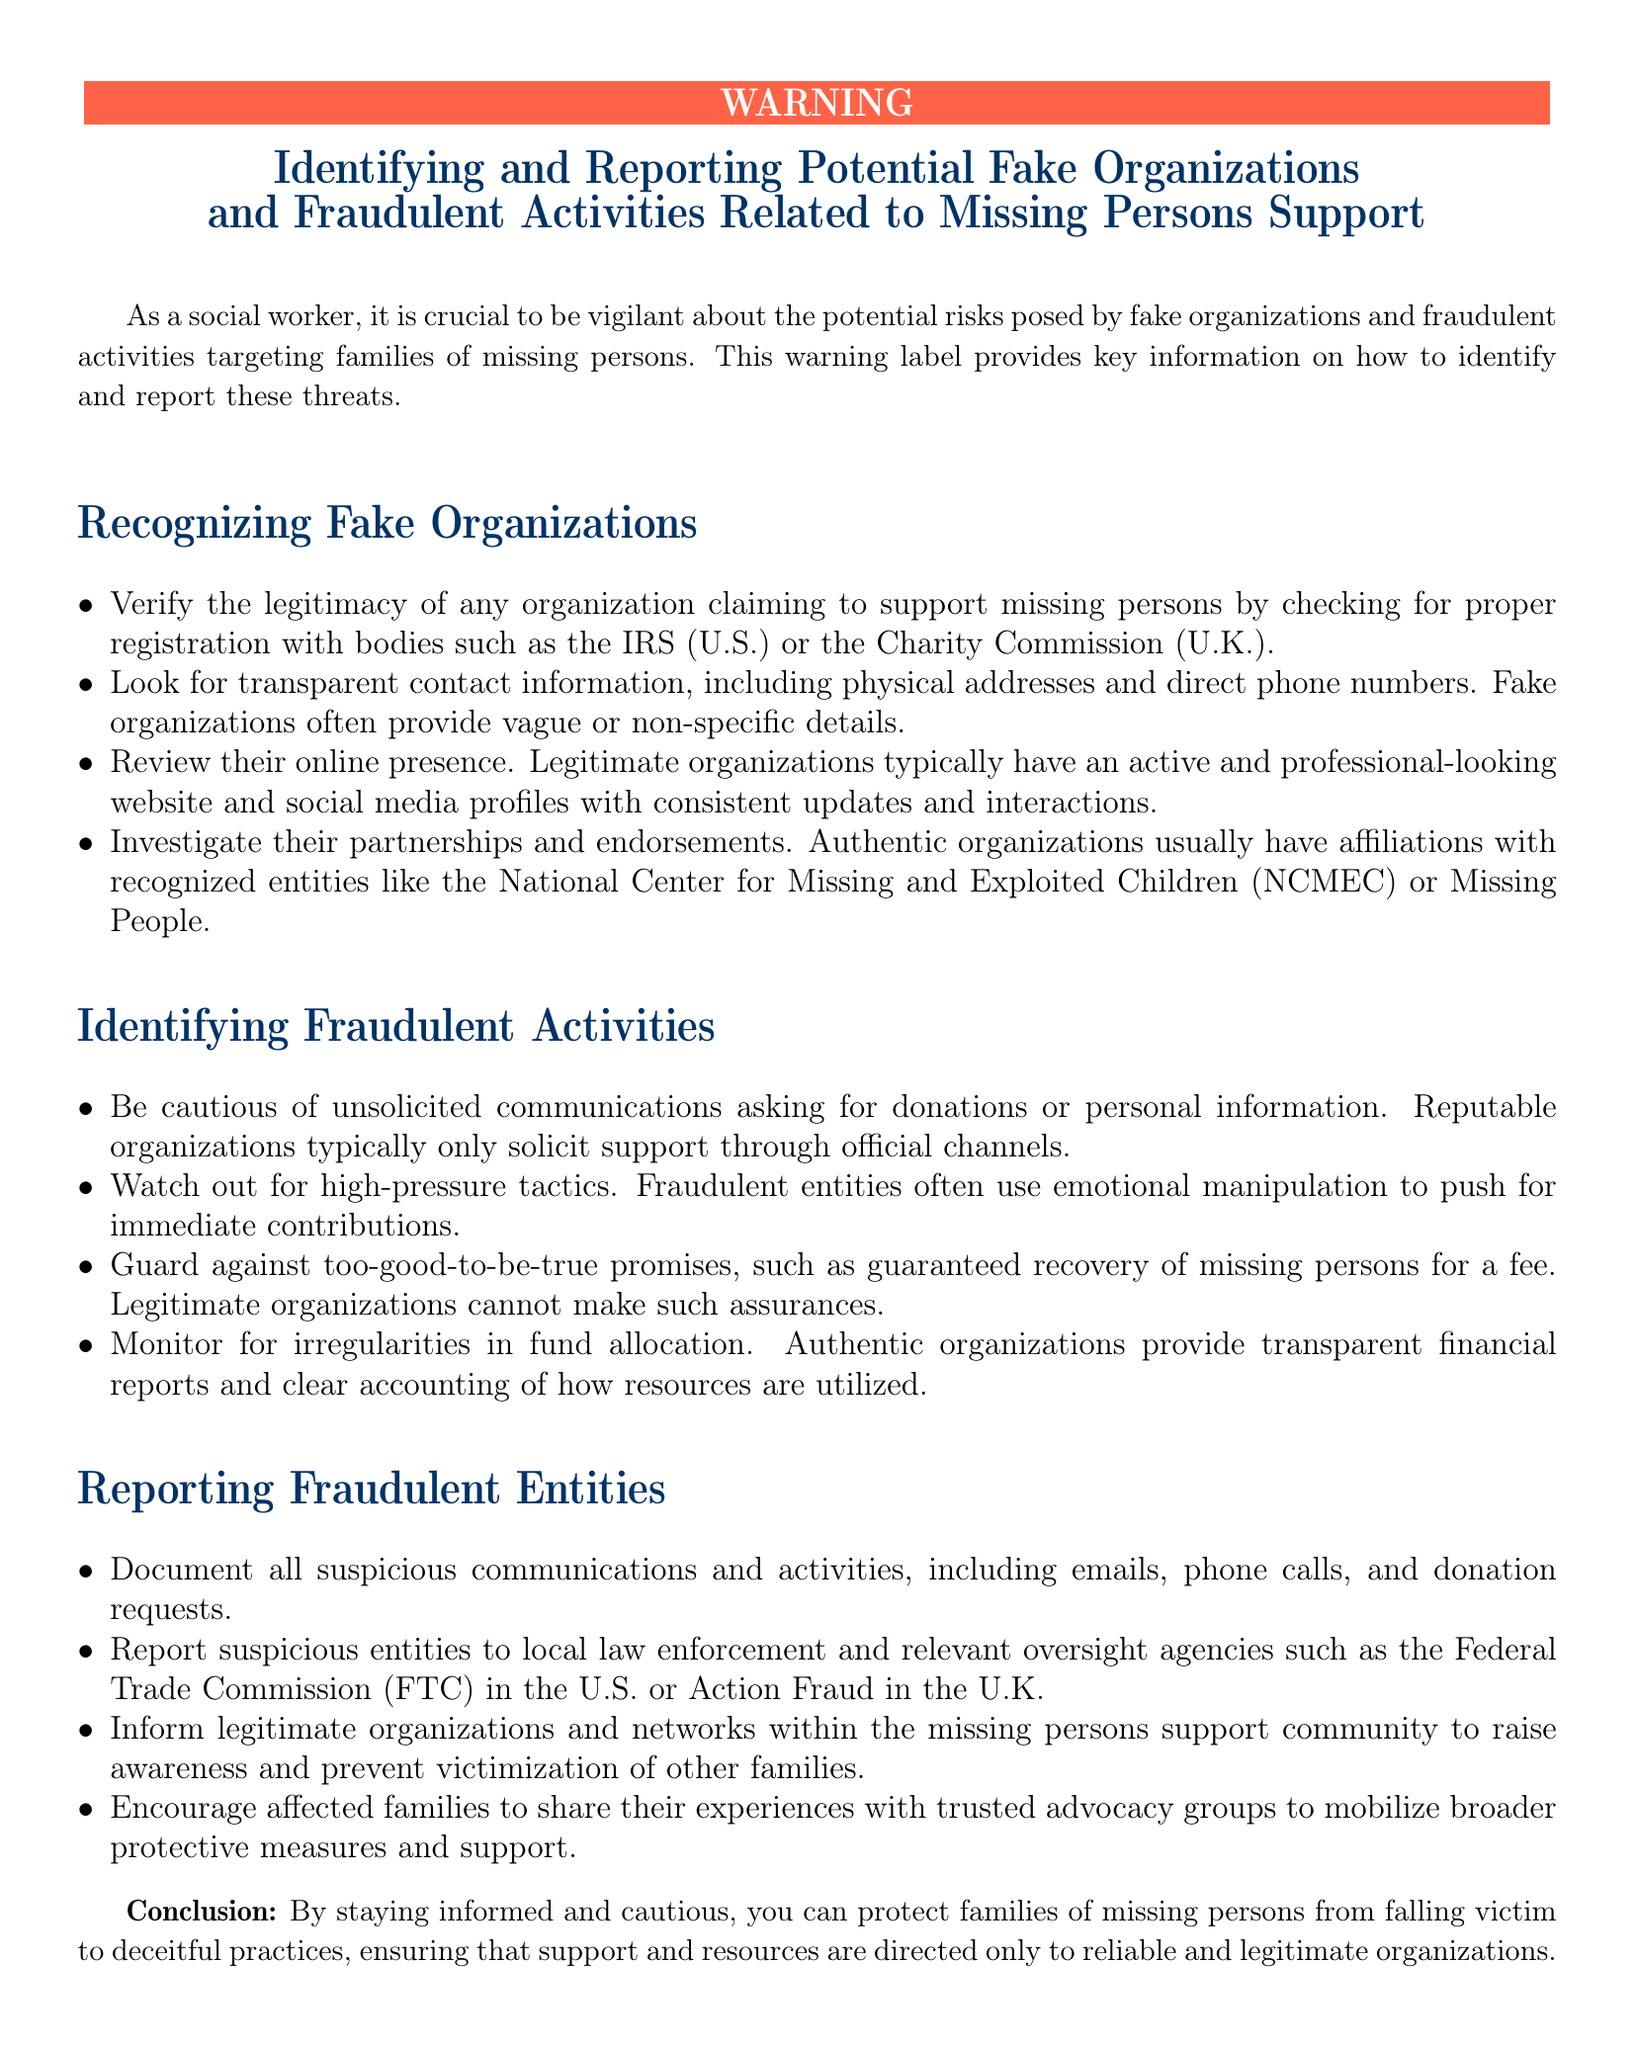What should you verify to ensure an organization's legitimacy? The document states to check for proper registration with bodies such as the IRS (U.S.) or the Charity Commission (U.K.).
Answer: proper registration What should you look for in contact information of organizations? According to the document, you should look for transparent contact information, including physical addresses and direct phone numbers.
Answer: transparent contact information What emotional tactic do fraudulent entities often use? The document highlights that high-pressure tactics are commonly used by fraudulent entities to manipulate emotions.
Answer: emotional manipulation Which organization is mentioned as a recognized entity to investigate partnerships with? The National Center for Missing and Exploited Children (NCMEC) is mentioned as a recognized entity for partnerships.
Answer: National Center for Missing and Exploited Children (NCMEC) What should you do with suspicious communications? The document advises to document all suspicious communications and activities.
Answer: document What can legitimate organizations not guarantee? The document states that legitimate organizations cannot make assurances about guaranteed recovery.
Answer: guaranteed recovery What oversight agency should suspicious entities be reported to in the U.S.? The Federal Trade Commission (FTC) is mentioned as an oversight agency to report suspicious entities in the U.S.
Answer: Federal Trade Commission (FTC) What is a sign of an authentic organization regarding financial reports? The document mentions that authentic organizations provide transparent financial reports.
Answer: transparent financial reports What is the main purpose of this warning label? The document concludes that the main purpose is to protect families of missing persons from deceitful practices.
Answer: protect families of missing persons 